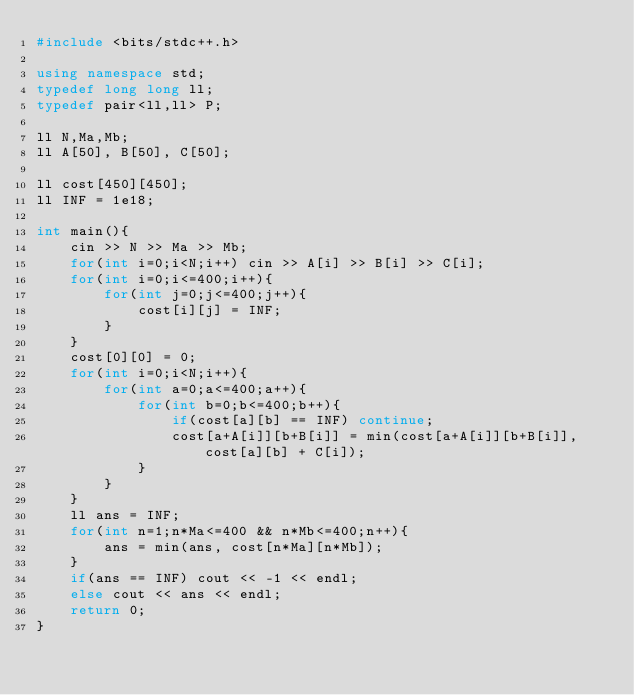<code> <loc_0><loc_0><loc_500><loc_500><_C++_>#include <bits/stdc++.h>

using namespace std;
typedef long long ll;
typedef pair<ll,ll> P;

ll N,Ma,Mb;
ll A[50], B[50], C[50];

ll cost[450][450];
ll INF = 1e18;

int main(){
    cin >> N >> Ma >> Mb;
    for(int i=0;i<N;i++) cin >> A[i] >> B[i] >> C[i];
    for(int i=0;i<=400;i++){
        for(int j=0;j<=400;j++){
            cost[i][j] = INF;
        }
    }
    cost[0][0] = 0;
    for(int i=0;i<N;i++){
        for(int a=0;a<=400;a++){
            for(int b=0;b<=400;b++){
                if(cost[a][b] == INF) continue;
                cost[a+A[i]][b+B[i]] = min(cost[a+A[i]][b+B[i]], cost[a][b] + C[i]);
            }
        }
    }
    ll ans = INF;
    for(int n=1;n*Ma<=400 && n*Mb<=400;n++){
        ans = min(ans, cost[n*Ma][n*Mb]);
    }
    if(ans == INF) cout << -1 << endl;
    else cout << ans << endl;
    return 0;
}</code> 